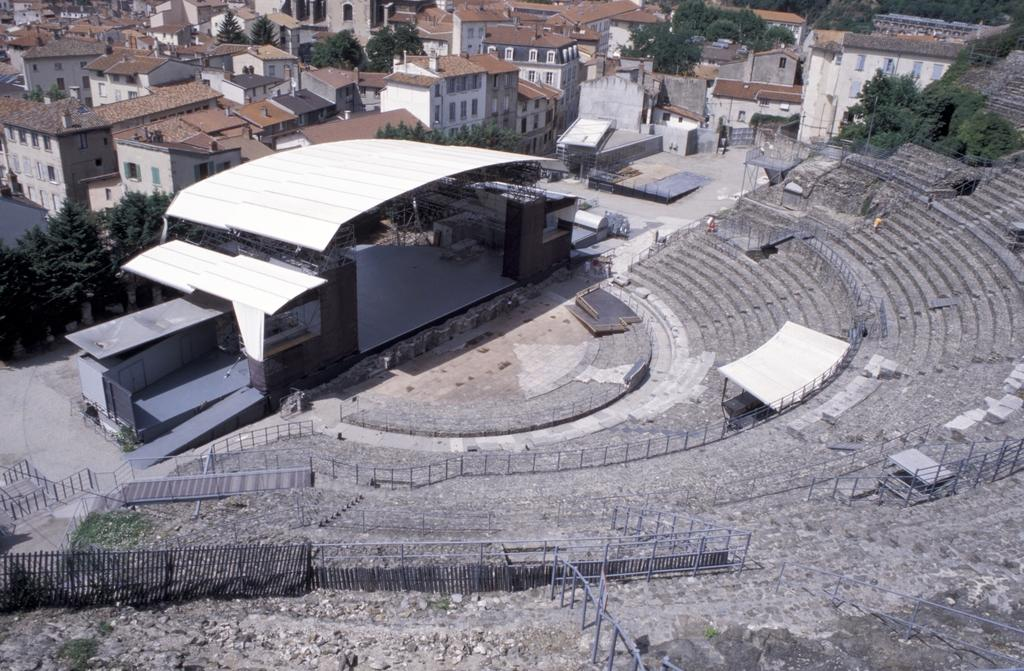What type of structure is visible in the image? There is an amphitheater in the image. Where is the amphitheater located? The amphitheater is located on a path. What type of fencing can be seen in the image? There are iron fences in the image. What can be seen behind the amphitheater? There are trees and buildings behind the amphitheater. What type of relation does the monkey have with the amphitheater in the image? There is no monkey present in the image, so it is not possible to determine any relation. 